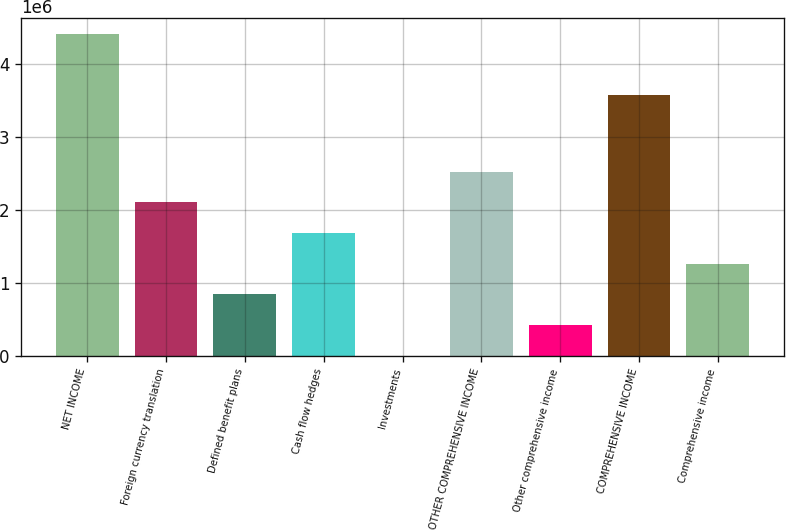<chart> <loc_0><loc_0><loc_500><loc_500><bar_chart><fcel>NET INCOME<fcel>Foreign currency translation<fcel>Defined benefit plans<fcel>Cash flow hedges<fcel>Investments<fcel>OTHER COMPREHENSIVE INCOME<fcel>Other comprehensive income<fcel>COMPREHENSIVE INCOME<fcel>Comprehensive income<nl><fcel>4.42121e+06<fcel>2.10787e+06<fcel>843837<fcel>1.68653e+06<fcel>1148<fcel>2.52922e+06<fcel>422493<fcel>3.57852e+06<fcel>1.26518e+06<nl></chart> 